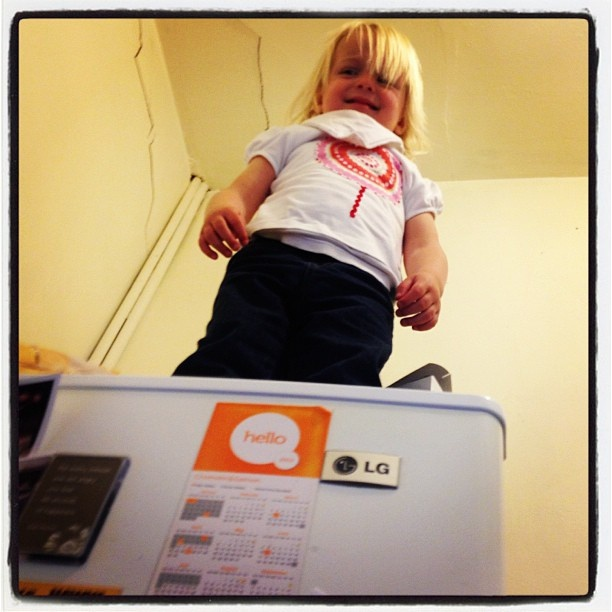Describe the objects in this image and their specific colors. I can see refrigerator in white, darkgray, lightgray, and gray tones and people in white, black, lightgray, and tan tones in this image. 